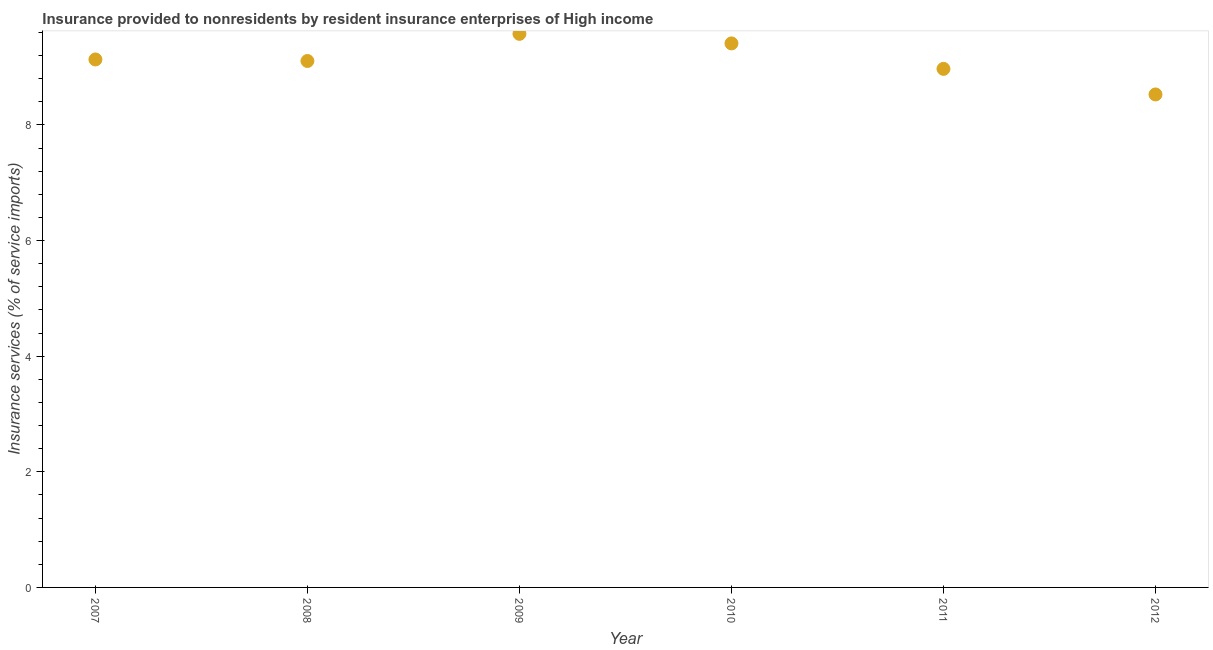What is the insurance and financial services in 2007?
Give a very brief answer. 9.13. Across all years, what is the maximum insurance and financial services?
Give a very brief answer. 9.58. Across all years, what is the minimum insurance and financial services?
Your answer should be compact. 8.53. In which year was the insurance and financial services maximum?
Your answer should be very brief. 2009. What is the sum of the insurance and financial services?
Your response must be concise. 54.72. What is the difference between the insurance and financial services in 2008 and 2010?
Your answer should be compact. -0.3. What is the average insurance and financial services per year?
Your response must be concise. 9.12. What is the median insurance and financial services?
Keep it short and to the point. 9.12. In how many years, is the insurance and financial services greater than 8.8 %?
Ensure brevity in your answer.  5. Do a majority of the years between 2009 and 2012 (inclusive) have insurance and financial services greater than 4 %?
Make the answer very short. Yes. What is the ratio of the insurance and financial services in 2008 to that in 2009?
Offer a terse response. 0.95. Is the insurance and financial services in 2009 less than that in 2011?
Give a very brief answer. No. Is the difference between the insurance and financial services in 2010 and 2011 greater than the difference between any two years?
Offer a very short reply. No. What is the difference between the highest and the second highest insurance and financial services?
Give a very brief answer. 0.16. What is the difference between the highest and the lowest insurance and financial services?
Provide a succinct answer. 1.05. Does the insurance and financial services monotonically increase over the years?
Offer a terse response. No. How many dotlines are there?
Your response must be concise. 1. How many years are there in the graph?
Offer a very short reply. 6. Are the values on the major ticks of Y-axis written in scientific E-notation?
Provide a succinct answer. No. Does the graph contain grids?
Provide a succinct answer. No. What is the title of the graph?
Give a very brief answer. Insurance provided to nonresidents by resident insurance enterprises of High income. What is the label or title of the Y-axis?
Ensure brevity in your answer.  Insurance services (% of service imports). What is the Insurance services (% of service imports) in 2007?
Provide a short and direct response. 9.13. What is the Insurance services (% of service imports) in 2008?
Your response must be concise. 9.11. What is the Insurance services (% of service imports) in 2009?
Your answer should be compact. 9.58. What is the Insurance services (% of service imports) in 2010?
Provide a succinct answer. 9.41. What is the Insurance services (% of service imports) in 2011?
Provide a short and direct response. 8.97. What is the Insurance services (% of service imports) in 2012?
Provide a succinct answer. 8.53. What is the difference between the Insurance services (% of service imports) in 2007 and 2008?
Give a very brief answer. 0.03. What is the difference between the Insurance services (% of service imports) in 2007 and 2009?
Make the answer very short. -0.44. What is the difference between the Insurance services (% of service imports) in 2007 and 2010?
Give a very brief answer. -0.28. What is the difference between the Insurance services (% of service imports) in 2007 and 2011?
Give a very brief answer. 0.16. What is the difference between the Insurance services (% of service imports) in 2007 and 2012?
Ensure brevity in your answer.  0.61. What is the difference between the Insurance services (% of service imports) in 2008 and 2009?
Ensure brevity in your answer.  -0.47. What is the difference between the Insurance services (% of service imports) in 2008 and 2010?
Your response must be concise. -0.3. What is the difference between the Insurance services (% of service imports) in 2008 and 2011?
Offer a terse response. 0.14. What is the difference between the Insurance services (% of service imports) in 2008 and 2012?
Ensure brevity in your answer.  0.58. What is the difference between the Insurance services (% of service imports) in 2009 and 2010?
Your answer should be compact. 0.16. What is the difference between the Insurance services (% of service imports) in 2009 and 2011?
Keep it short and to the point. 0.61. What is the difference between the Insurance services (% of service imports) in 2009 and 2012?
Your answer should be compact. 1.05. What is the difference between the Insurance services (% of service imports) in 2010 and 2011?
Ensure brevity in your answer.  0.44. What is the difference between the Insurance services (% of service imports) in 2010 and 2012?
Provide a succinct answer. 0.88. What is the difference between the Insurance services (% of service imports) in 2011 and 2012?
Keep it short and to the point. 0.44. What is the ratio of the Insurance services (% of service imports) in 2007 to that in 2009?
Offer a terse response. 0.95. What is the ratio of the Insurance services (% of service imports) in 2007 to that in 2010?
Offer a terse response. 0.97. What is the ratio of the Insurance services (% of service imports) in 2007 to that in 2011?
Provide a short and direct response. 1.02. What is the ratio of the Insurance services (% of service imports) in 2007 to that in 2012?
Your response must be concise. 1.07. What is the ratio of the Insurance services (% of service imports) in 2008 to that in 2009?
Keep it short and to the point. 0.95. What is the ratio of the Insurance services (% of service imports) in 2008 to that in 2011?
Ensure brevity in your answer.  1.01. What is the ratio of the Insurance services (% of service imports) in 2008 to that in 2012?
Your answer should be compact. 1.07. What is the ratio of the Insurance services (% of service imports) in 2009 to that in 2010?
Provide a succinct answer. 1.02. What is the ratio of the Insurance services (% of service imports) in 2009 to that in 2011?
Make the answer very short. 1.07. What is the ratio of the Insurance services (% of service imports) in 2009 to that in 2012?
Keep it short and to the point. 1.12. What is the ratio of the Insurance services (% of service imports) in 2010 to that in 2011?
Offer a terse response. 1.05. What is the ratio of the Insurance services (% of service imports) in 2010 to that in 2012?
Provide a short and direct response. 1.1. What is the ratio of the Insurance services (% of service imports) in 2011 to that in 2012?
Give a very brief answer. 1.05. 